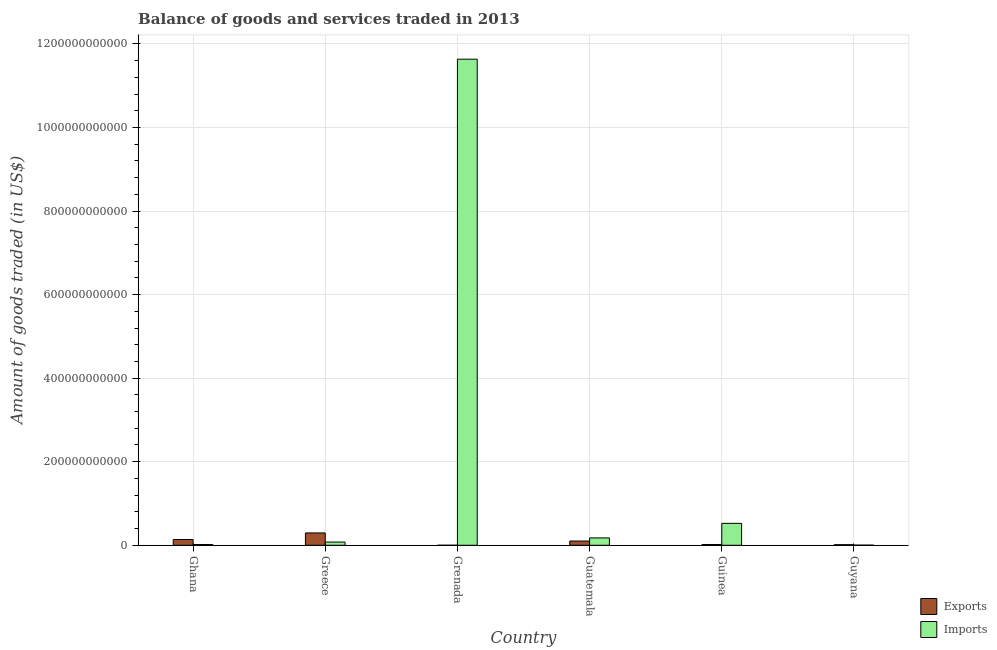How many different coloured bars are there?
Your response must be concise. 2. How many bars are there on the 5th tick from the left?
Keep it short and to the point. 2. How many bars are there on the 1st tick from the right?
Offer a very short reply. 2. What is the label of the 4th group of bars from the left?
Give a very brief answer. Guatemala. In how many cases, is the number of bars for a given country not equal to the number of legend labels?
Provide a short and direct response. 0. What is the amount of goods exported in Guyana?
Make the answer very short. 1.38e+09. Across all countries, what is the maximum amount of goods imported?
Your answer should be very brief. 1.16e+12. Across all countries, what is the minimum amount of goods imported?
Provide a short and direct response. 3.24e+08. In which country was the amount of goods imported maximum?
Offer a very short reply. Grenada. In which country was the amount of goods exported minimum?
Your answer should be very brief. Grenada. What is the total amount of goods imported in the graph?
Your response must be concise. 1.24e+12. What is the difference between the amount of goods exported in Guatemala and that in Guinea?
Provide a succinct answer. 8.30e+09. What is the difference between the amount of goods imported in Ghana and the amount of goods exported in Grenada?
Provide a succinct answer. 1.74e+09. What is the average amount of goods imported per country?
Provide a succinct answer. 2.07e+11. What is the difference between the amount of goods exported and amount of goods imported in Guyana?
Your answer should be compact. 1.05e+09. What is the ratio of the amount of goods exported in Grenada to that in Guyana?
Your response must be concise. 0.03. Is the amount of goods exported in Grenada less than that in Guinea?
Your answer should be compact. Yes. What is the difference between the highest and the second highest amount of goods imported?
Provide a succinct answer. 1.11e+12. What is the difference between the highest and the lowest amount of goods imported?
Your response must be concise. 1.16e+12. Is the sum of the amount of goods imported in Ghana and Guinea greater than the maximum amount of goods exported across all countries?
Offer a terse response. Yes. What does the 1st bar from the left in Guinea represents?
Give a very brief answer. Exports. What does the 1st bar from the right in Greece represents?
Offer a very short reply. Imports. How many bars are there?
Ensure brevity in your answer.  12. How many countries are there in the graph?
Offer a very short reply. 6. What is the difference between two consecutive major ticks on the Y-axis?
Offer a terse response. 2.00e+11. Does the graph contain any zero values?
Offer a very short reply. No. How many legend labels are there?
Make the answer very short. 2. What is the title of the graph?
Keep it short and to the point. Balance of goods and services traded in 2013. What is the label or title of the X-axis?
Make the answer very short. Country. What is the label or title of the Y-axis?
Provide a short and direct response. Amount of goods traded (in US$). What is the Amount of goods traded (in US$) in Exports in Ghana?
Keep it short and to the point. 1.38e+1. What is the Amount of goods traded (in US$) of Imports in Ghana?
Give a very brief answer. 1.78e+09. What is the Amount of goods traded (in US$) of Exports in Greece?
Your answer should be compact. 2.96e+1. What is the Amount of goods traded (in US$) in Imports in Greece?
Your answer should be very brief. 7.70e+09. What is the Amount of goods traded (in US$) of Exports in Grenada?
Your answer should be very brief. 4.65e+07. What is the Amount of goods traded (in US$) in Imports in Grenada?
Ensure brevity in your answer.  1.16e+12. What is the Amount of goods traded (in US$) of Exports in Guatemala?
Keep it short and to the point. 1.02e+1. What is the Amount of goods traded (in US$) in Imports in Guatemala?
Give a very brief answer. 1.76e+1. What is the Amount of goods traded (in US$) in Exports in Guinea?
Provide a succinct answer. 1.89e+09. What is the Amount of goods traded (in US$) in Imports in Guinea?
Your response must be concise. 5.25e+1. What is the Amount of goods traded (in US$) in Exports in Guyana?
Your answer should be very brief. 1.38e+09. What is the Amount of goods traded (in US$) in Imports in Guyana?
Make the answer very short. 3.24e+08. Across all countries, what is the maximum Amount of goods traded (in US$) in Exports?
Make the answer very short. 2.96e+1. Across all countries, what is the maximum Amount of goods traded (in US$) in Imports?
Keep it short and to the point. 1.16e+12. Across all countries, what is the minimum Amount of goods traded (in US$) of Exports?
Your answer should be very brief. 4.65e+07. Across all countries, what is the minimum Amount of goods traded (in US$) in Imports?
Keep it short and to the point. 3.24e+08. What is the total Amount of goods traded (in US$) of Exports in the graph?
Offer a terse response. 5.68e+1. What is the total Amount of goods traded (in US$) in Imports in the graph?
Your answer should be compact. 1.24e+12. What is the difference between the Amount of goods traded (in US$) of Exports in Ghana and that in Greece?
Give a very brief answer. -1.58e+1. What is the difference between the Amount of goods traded (in US$) in Imports in Ghana and that in Greece?
Provide a succinct answer. -5.91e+09. What is the difference between the Amount of goods traded (in US$) of Exports in Ghana and that in Grenada?
Keep it short and to the point. 1.37e+1. What is the difference between the Amount of goods traded (in US$) in Imports in Ghana and that in Grenada?
Offer a terse response. -1.16e+12. What is the difference between the Amount of goods traded (in US$) of Exports in Ghana and that in Guatemala?
Make the answer very short. 3.57e+09. What is the difference between the Amount of goods traded (in US$) in Imports in Ghana and that in Guatemala?
Provide a short and direct response. -1.58e+1. What is the difference between the Amount of goods traded (in US$) of Exports in Ghana and that in Guinea?
Your answer should be very brief. 1.19e+1. What is the difference between the Amount of goods traded (in US$) in Imports in Ghana and that in Guinea?
Give a very brief answer. -5.07e+1. What is the difference between the Amount of goods traded (in US$) in Exports in Ghana and that in Guyana?
Your answer should be compact. 1.24e+1. What is the difference between the Amount of goods traded (in US$) of Imports in Ghana and that in Guyana?
Provide a short and direct response. 1.46e+09. What is the difference between the Amount of goods traded (in US$) in Exports in Greece and that in Grenada?
Give a very brief answer. 2.95e+1. What is the difference between the Amount of goods traded (in US$) of Imports in Greece and that in Grenada?
Ensure brevity in your answer.  -1.16e+12. What is the difference between the Amount of goods traded (in US$) of Exports in Greece and that in Guatemala?
Your response must be concise. 1.94e+1. What is the difference between the Amount of goods traded (in US$) of Imports in Greece and that in Guatemala?
Give a very brief answer. -9.90e+09. What is the difference between the Amount of goods traded (in US$) of Exports in Greece and that in Guinea?
Ensure brevity in your answer.  2.77e+1. What is the difference between the Amount of goods traded (in US$) in Imports in Greece and that in Guinea?
Your answer should be compact. -4.48e+1. What is the difference between the Amount of goods traded (in US$) in Exports in Greece and that in Guyana?
Ensure brevity in your answer.  2.82e+1. What is the difference between the Amount of goods traded (in US$) of Imports in Greece and that in Guyana?
Make the answer very short. 7.37e+09. What is the difference between the Amount of goods traded (in US$) in Exports in Grenada and that in Guatemala?
Give a very brief answer. -1.01e+1. What is the difference between the Amount of goods traded (in US$) of Imports in Grenada and that in Guatemala?
Make the answer very short. 1.15e+12. What is the difference between the Amount of goods traded (in US$) in Exports in Grenada and that in Guinea?
Keep it short and to the point. -1.84e+09. What is the difference between the Amount of goods traded (in US$) of Imports in Grenada and that in Guinea?
Make the answer very short. 1.11e+12. What is the difference between the Amount of goods traded (in US$) in Exports in Grenada and that in Guyana?
Keep it short and to the point. -1.33e+09. What is the difference between the Amount of goods traded (in US$) of Imports in Grenada and that in Guyana?
Your answer should be very brief. 1.16e+12. What is the difference between the Amount of goods traded (in US$) in Exports in Guatemala and that in Guinea?
Your response must be concise. 8.30e+09. What is the difference between the Amount of goods traded (in US$) in Imports in Guatemala and that in Guinea?
Your response must be concise. -3.49e+1. What is the difference between the Amount of goods traded (in US$) of Exports in Guatemala and that in Guyana?
Make the answer very short. 8.81e+09. What is the difference between the Amount of goods traded (in US$) in Imports in Guatemala and that in Guyana?
Give a very brief answer. 1.73e+1. What is the difference between the Amount of goods traded (in US$) of Exports in Guinea and that in Guyana?
Keep it short and to the point. 5.10e+08. What is the difference between the Amount of goods traded (in US$) in Imports in Guinea and that in Guyana?
Keep it short and to the point. 5.21e+1. What is the difference between the Amount of goods traded (in US$) of Exports in Ghana and the Amount of goods traded (in US$) of Imports in Greece?
Provide a short and direct response. 6.05e+09. What is the difference between the Amount of goods traded (in US$) in Exports in Ghana and the Amount of goods traded (in US$) in Imports in Grenada?
Your answer should be very brief. -1.15e+12. What is the difference between the Amount of goods traded (in US$) in Exports in Ghana and the Amount of goods traded (in US$) in Imports in Guatemala?
Your answer should be very brief. -3.85e+09. What is the difference between the Amount of goods traded (in US$) in Exports in Ghana and the Amount of goods traded (in US$) in Imports in Guinea?
Your answer should be very brief. -3.87e+1. What is the difference between the Amount of goods traded (in US$) in Exports in Ghana and the Amount of goods traded (in US$) in Imports in Guyana?
Your answer should be compact. 1.34e+1. What is the difference between the Amount of goods traded (in US$) of Exports in Greece and the Amount of goods traded (in US$) of Imports in Grenada?
Give a very brief answer. -1.13e+12. What is the difference between the Amount of goods traded (in US$) of Exports in Greece and the Amount of goods traded (in US$) of Imports in Guatemala?
Offer a very short reply. 1.20e+1. What is the difference between the Amount of goods traded (in US$) in Exports in Greece and the Amount of goods traded (in US$) in Imports in Guinea?
Your response must be concise. -2.29e+1. What is the difference between the Amount of goods traded (in US$) of Exports in Greece and the Amount of goods traded (in US$) of Imports in Guyana?
Provide a short and direct response. 2.92e+1. What is the difference between the Amount of goods traded (in US$) of Exports in Grenada and the Amount of goods traded (in US$) of Imports in Guatemala?
Your answer should be very brief. -1.76e+1. What is the difference between the Amount of goods traded (in US$) in Exports in Grenada and the Amount of goods traded (in US$) in Imports in Guinea?
Keep it short and to the point. -5.24e+1. What is the difference between the Amount of goods traded (in US$) of Exports in Grenada and the Amount of goods traded (in US$) of Imports in Guyana?
Your answer should be compact. -2.78e+08. What is the difference between the Amount of goods traded (in US$) of Exports in Guatemala and the Amount of goods traded (in US$) of Imports in Guinea?
Provide a short and direct response. -4.23e+1. What is the difference between the Amount of goods traded (in US$) of Exports in Guatemala and the Amount of goods traded (in US$) of Imports in Guyana?
Make the answer very short. 9.86e+09. What is the difference between the Amount of goods traded (in US$) in Exports in Guinea and the Amount of goods traded (in US$) in Imports in Guyana?
Offer a terse response. 1.56e+09. What is the average Amount of goods traded (in US$) in Exports per country?
Your answer should be compact. 9.47e+09. What is the average Amount of goods traded (in US$) in Imports per country?
Your response must be concise. 2.07e+11. What is the difference between the Amount of goods traded (in US$) in Exports and Amount of goods traded (in US$) in Imports in Ghana?
Your answer should be compact. 1.20e+1. What is the difference between the Amount of goods traded (in US$) of Exports and Amount of goods traded (in US$) of Imports in Greece?
Make the answer very short. 2.19e+1. What is the difference between the Amount of goods traded (in US$) in Exports and Amount of goods traded (in US$) in Imports in Grenada?
Your answer should be compact. -1.16e+12. What is the difference between the Amount of goods traded (in US$) of Exports and Amount of goods traded (in US$) of Imports in Guatemala?
Your answer should be compact. -7.42e+09. What is the difference between the Amount of goods traded (in US$) in Exports and Amount of goods traded (in US$) in Imports in Guinea?
Make the answer very short. -5.06e+1. What is the difference between the Amount of goods traded (in US$) in Exports and Amount of goods traded (in US$) in Imports in Guyana?
Your answer should be very brief. 1.05e+09. What is the ratio of the Amount of goods traded (in US$) of Exports in Ghana to that in Greece?
Provide a short and direct response. 0.47. What is the ratio of the Amount of goods traded (in US$) in Imports in Ghana to that in Greece?
Make the answer very short. 0.23. What is the ratio of the Amount of goods traded (in US$) in Exports in Ghana to that in Grenada?
Ensure brevity in your answer.  295.61. What is the ratio of the Amount of goods traded (in US$) of Imports in Ghana to that in Grenada?
Provide a succinct answer. 0. What is the ratio of the Amount of goods traded (in US$) of Exports in Ghana to that in Guatemala?
Ensure brevity in your answer.  1.35. What is the ratio of the Amount of goods traded (in US$) in Imports in Ghana to that in Guatemala?
Your answer should be compact. 0.1. What is the ratio of the Amount of goods traded (in US$) of Exports in Ghana to that in Guinea?
Your answer should be very brief. 7.29. What is the ratio of the Amount of goods traded (in US$) in Imports in Ghana to that in Guinea?
Offer a very short reply. 0.03. What is the ratio of the Amount of goods traded (in US$) in Exports in Ghana to that in Guyana?
Ensure brevity in your answer.  9.99. What is the ratio of the Amount of goods traded (in US$) in Imports in Ghana to that in Guyana?
Your response must be concise. 5.5. What is the ratio of the Amount of goods traded (in US$) in Exports in Greece to that in Grenada?
Provide a succinct answer. 635.22. What is the ratio of the Amount of goods traded (in US$) of Imports in Greece to that in Grenada?
Keep it short and to the point. 0.01. What is the ratio of the Amount of goods traded (in US$) in Exports in Greece to that in Guatemala?
Provide a short and direct response. 2.9. What is the ratio of the Amount of goods traded (in US$) in Imports in Greece to that in Guatemala?
Provide a succinct answer. 0.44. What is the ratio of the Amount of goods traded (in US$) in Exports in Greece to that in Guinea?
Offer a very short reply. 15.67. What is the ratio of the Amount of goods traded (in US$) in Imports in Greece to that in Guinea?
Your answer should be very brief. 0.15. What is the ratio of the Amount of goods traded (in US$) of Exports in Greece to that in Guyana?
Keep it short and to the point. 21.48. What is the ratio of the Amount of goods traded (in US$) in Imports in Greece to that in Guyana?
Ensure brevity in your answer.  23.74. What is the ratio of the Amount of goods traded (in US$) in Exports in Grenada to that in Guatemala?
Offer a terse response. 0. What is the ratio of the Amount of goods traded (in US$) of Imports in Grenada to that in Guatemala?
Give a very brief answer. 66.1. What is the ratio of the Amount of goods traded (in US$) of Exports in Grenada to that in Guinea?
Your answer should be very brief. 0.02. What is the ratio of the Amount of goods traded (in US$) in Imports in Grenada to that in Guinea?
Your answer should be compact. 22.18. What is the ratio of the Amount of goods traded (in US$) of Exports in Grenada to that in Guyana?
Ensure brevity in your answer.  0.03. What is the ratio of the Amount of goods traded (in US$) in Imports in Grenada to that in Guyana?
Provide a short and direct response. 3588.28. What is the ratio of the Amount of goods traded (in US$) in Exports in Guatemala to that in Guinea?
Ensure brevity in your answer.  5.4. What is the ratio of the Amount of goods traded (in US$) of Imports in Guatemala to that in Guinea?
Provide a short and direct response. 0.34. What is the ratio of the Amount of goods traded (in US$) of Exports in Guatemala to that in Guyana?
Your response must be concise. 7.4. What is the ratio of the Amount of goods traded (in US$) of Imports in Guatemala to that in Guyana?
Offer a very short reply. 54.28. What is the ratio of the Amount of goods traded (in US$) of Exports in Guinea to that in Guyana?
Your answer should be compact. 1.37. What is the ratio of the Amount of goods traded (in US$) of Imports in Guinea to that in Guyana?
Keep it short and to the point. 161.78. What is the difference between the highest and the second highest Amount of goods traded (in US$) in Exports?
Your answer should be compact. 1.58e+1. What is the difference between the highest and the second highest Amount of goods traded (in US$) in Imports?
Give a very brief answer. 1.11e+12. What is the difference between the highest and the lowest Amount of goods traded (in US$) in Exports?
Keep it short and to the point. 2.95e+1. What is the difference between the highest and the lowest Amount of goods traded (in US$) in Imports?
Your response must be concise. 1.16e+12. 